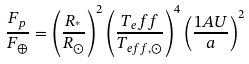<formula> <loc_0><loc_0><loc_500><loc_500>\frac { F _ { p } } { F _ { \oplus } } = \left ( \frac { R _ { ^ { * } } } { R _ { \odot } } \right ) ^ { 2 } \left ( \frac { T _ { e } f f } { T _ { e f f , \odot } } \right ) ^ { 4 } \left ( \frac { 1 A U } { a } \right ) ^ { 2 }</formula> 